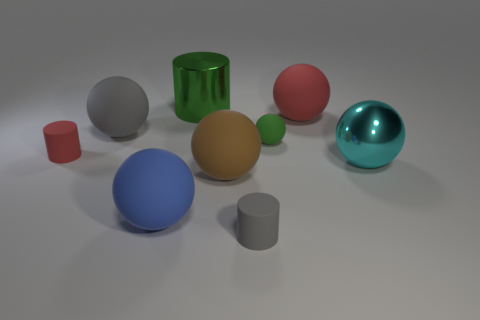Subtract all rubber cylinders. How many cylinders are left? 1 Add 1 large red objects. How many objects exist? 10 Subtract all green balls. How many balls are left? 5 Subtract all cylinders. How many objects are left? 6 Subtract all brown shiny balls. Subtract all tiny rubber things. How many objects are left? 6 Add 2 large green cylinders. How many large green cylinders are left? 3 Add 3 gray objects. How many gray objects exist? 5 Subtract 0 cyan cylinders. How many objects are left? 9 Subtract all red balls. Subtract all cyan cubes. How many balls are left? 5 